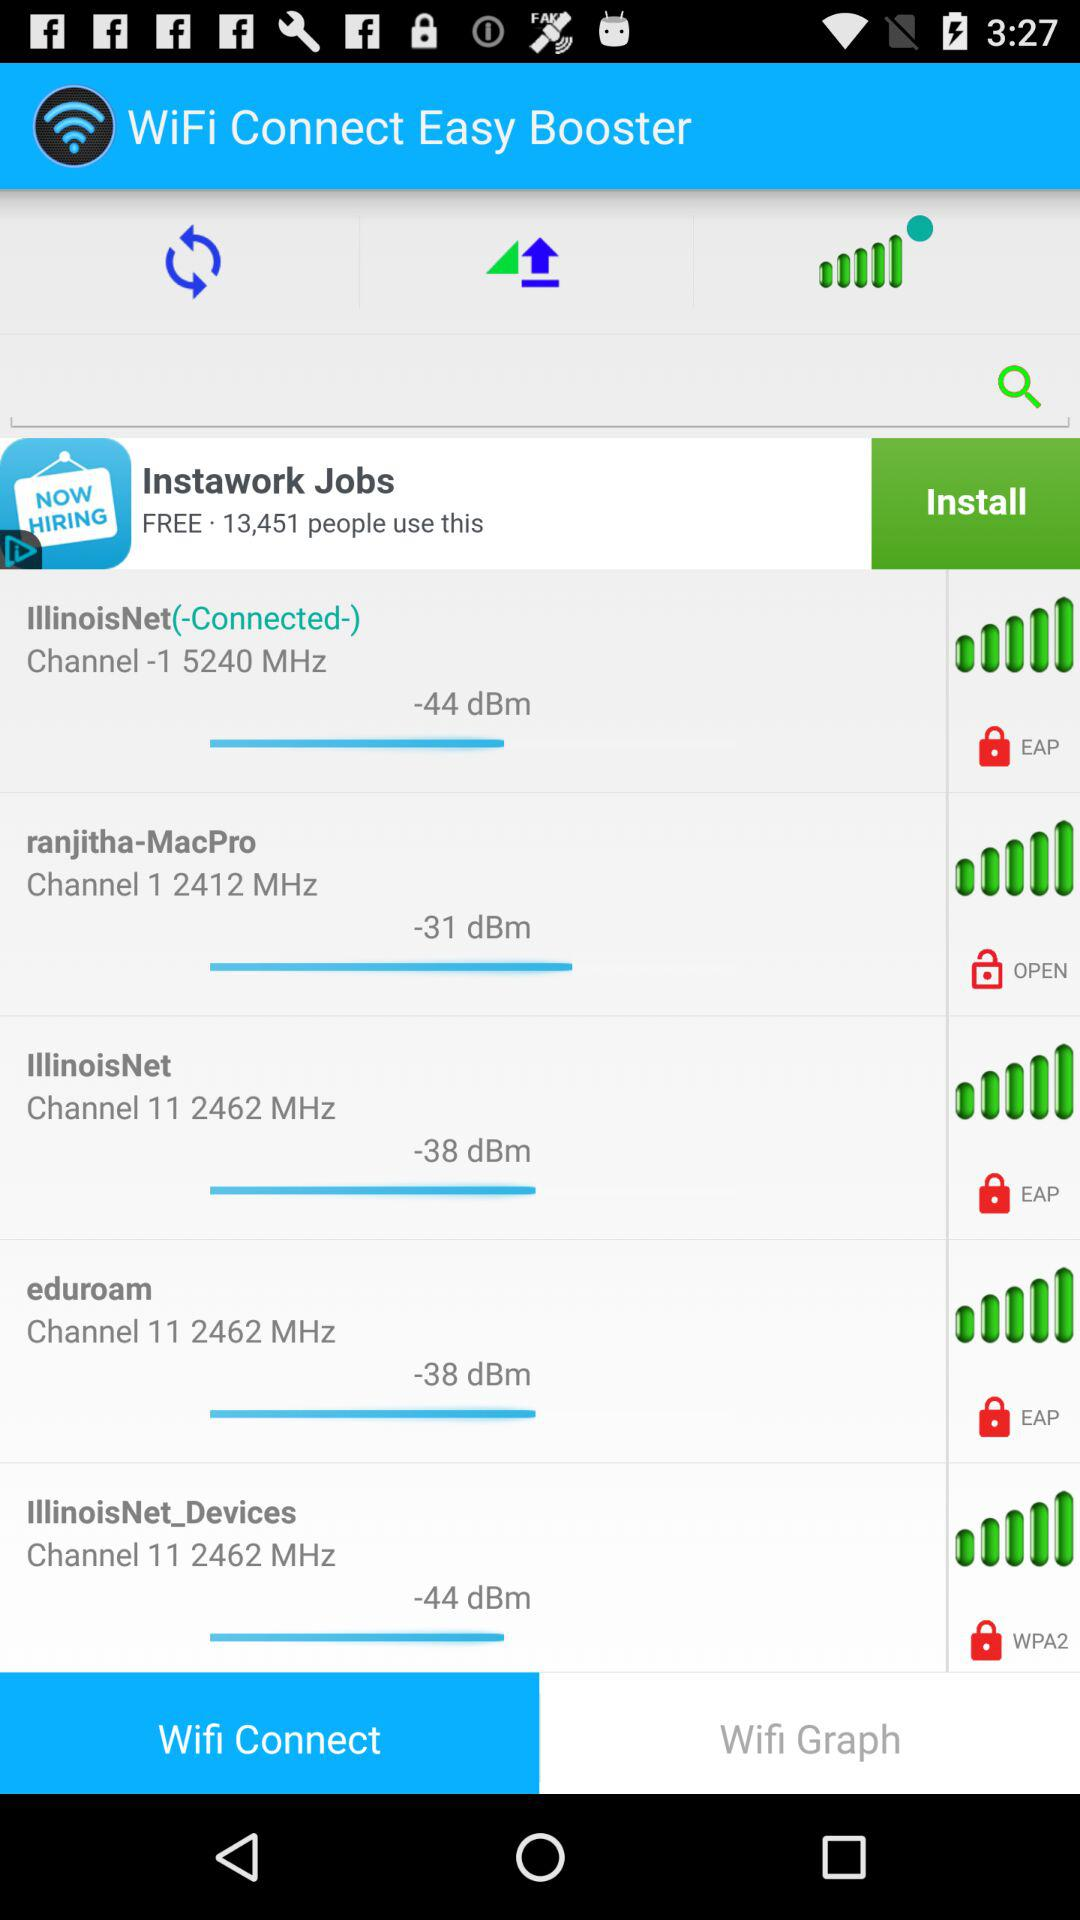What wifi is it connected to? It is connected with IllinoisNet WiFi. 